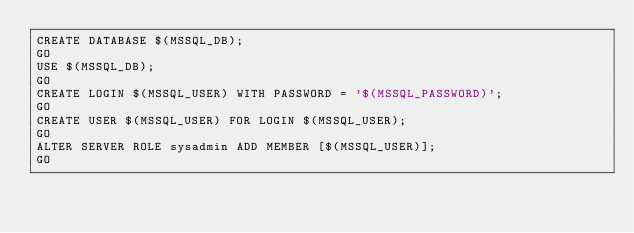Convert code to text. <code><loc_0><loc_0><loc_500><loc_500><_SQL_>CREATE DATABASE $(MSSQL_DB);
GO
USE $(MSSQL_DB);
GO
CREATE LOGIN $(MSSQL_USER) WITH PASSWORD = '$(MSSQL_PASSWORD)';
GO
CREATE USER $(MSSQL_USER) FOR LOGIN $(MSSQL_USER);
GO
ALTER SERVER ROLE sysadmin ADD MEMBER [$(MSSQL_USER)];
GO</code> 